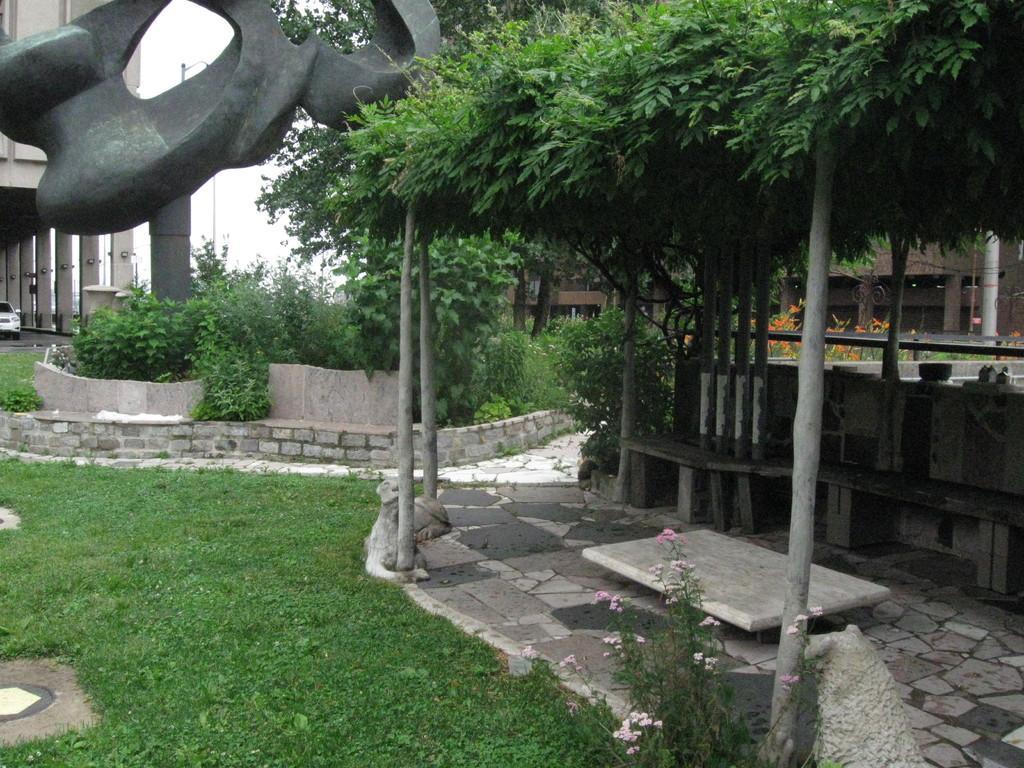Describe this image in one or two sentences. In the image we can grass, plants and there are benches. This is a sculpture, cement in color. There are even buildings and we can even see a vehicle. 